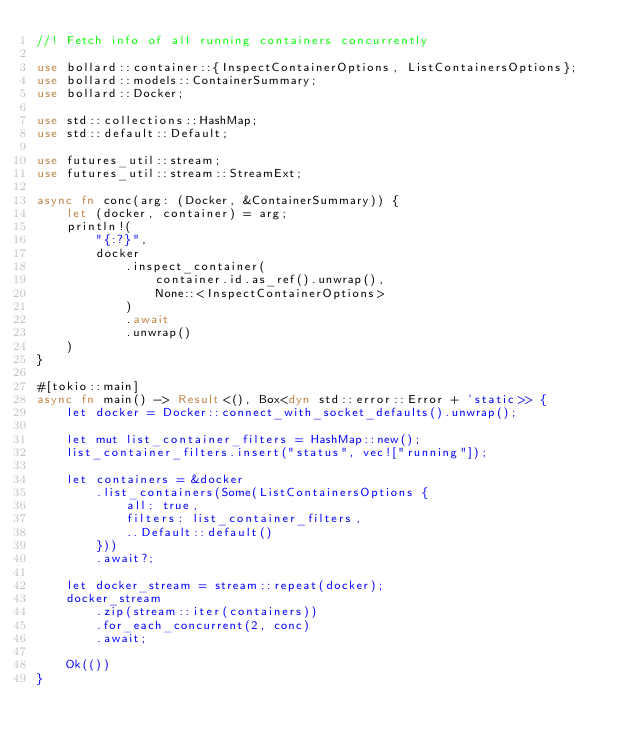<code> <loc_0><loc_0><loc_500><loc_500><_Rust_>//! Fetch info of all running containers concurrently

use bollard::container::{InspectContainerOptions, ListContainersOptions};
use bollard::models::ContainerSummary;
use bollard::Docker;

use std::collections::HashMap;
use std::default::Default;

use futures_util::stream;
use futures_util::stream::StreamExt;

async fn conc(arg: (Docker, &ContainerSummary)) {
    let (docker, container) = arg;
    println!(
        "{:?}",
        docker
            .inspect_container(
                container.id.as_ref().unwrap(),
                None::<InspectContainerOptions>
            )
            .await
            .unwrap()
    )
}

#[tokio::main]
async fn main() -> Result<(), Box<dyn std::error::Error + 'static>> {
    let docker = Docker::connect_with_socket_defaults().unwrap();

    let mut list_container_filters = HashMap::new();
    list_container_filters.insert("status", vec!["running"]);

    let containers = &docker
        .list_containers(Some(ListContainersOptions {
            all: true,
            filters: list_container_filters,
            ..Default::default()
        }))
        .await?;

    let docker_stream = stream::repeat(docker);
    docker_stream
        .zip(stream::iter(containers))
        .for_each_concurrent(2, conc)
        .await;

    Ok(())
}
</code> 